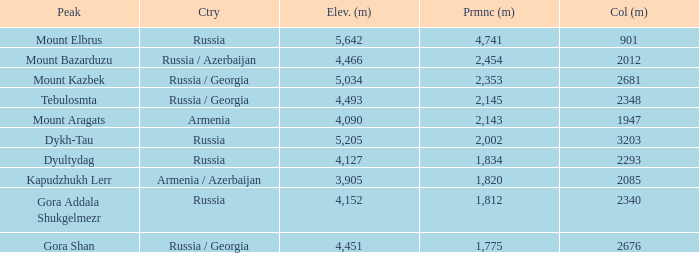What is the Elevation (m) of the Peak with a Prominence (m) larger than 2,143 and Col (m) of 2012? 4466.0. 